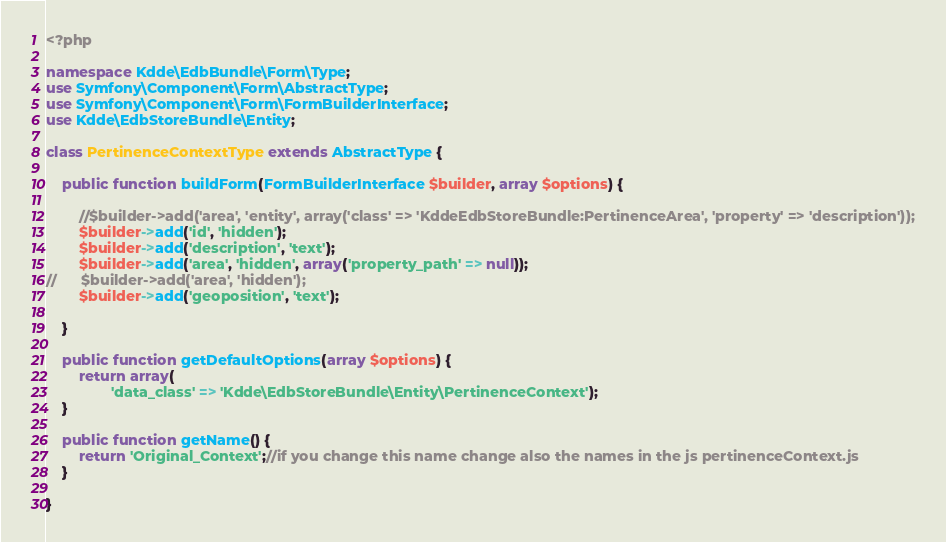<code> <loc_0><loc_0><loc_500><loc_500><_PHP_><?php

namespace Kdde\EdbBundle\Form\Type;
use Symfony\Component\Form\AbstractType;
use Symfony\Component\Form\FormBuilderInterface;
use Kdde\EdbStoreBundle\Entity;

class PertinenceContextType extends AbstractType {

	public function buildForm(FormBuilderInterface $builder, array $options) {

		//$builder->add('area', 'entity', array('class' => 'KddeEdbStoreBundle:PertinenceArea', 'property' => 'description'));
		$builder->add('id', 'hidden');
		$builder->add('description', 'text');
		$builder->add('area', 'hidden', array('property_path' => null));
// 		$builder->add('area', 'hidden');
		$builder->add('geoposition', 'text');

	}

	public function getDefaultOptions(array $options) {
		return array(
				'data_class' => 'Kdde\EdbStoreBundle\Entity\PertinenceContext');
	}

	public function getName() {
		return 'Original_Context';//if you change this name change also the names in the js pertinenceContext.js
	}

}
</code> 